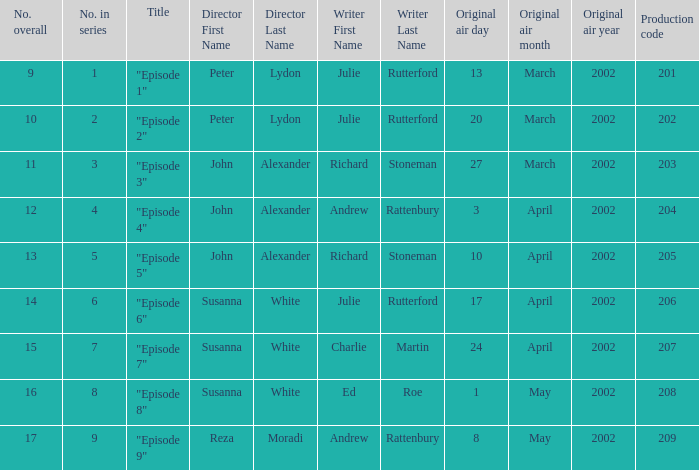When 15 is the number overall what is the original air date? 24April2002. 